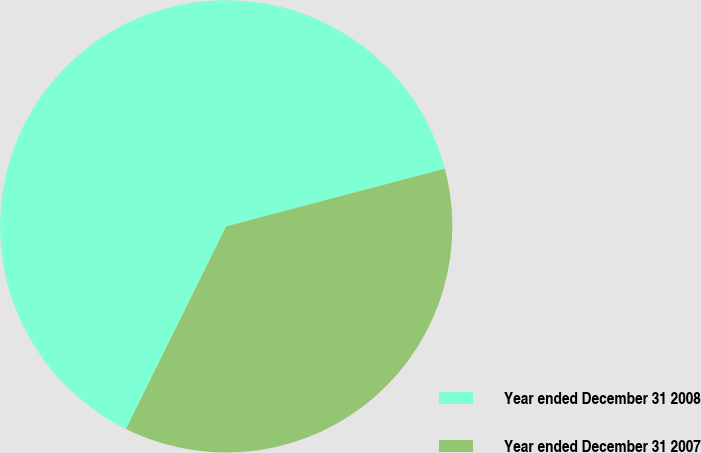Convert chart to OTSL. <chart><loc_0><loc_0><loc_500><loc_500><pie_chart><fcel>Year ended December 31 2008<fcel>Year ended December 31 2007<nl><fcel>63.58%<fcel>36.42%<nl></chart> 